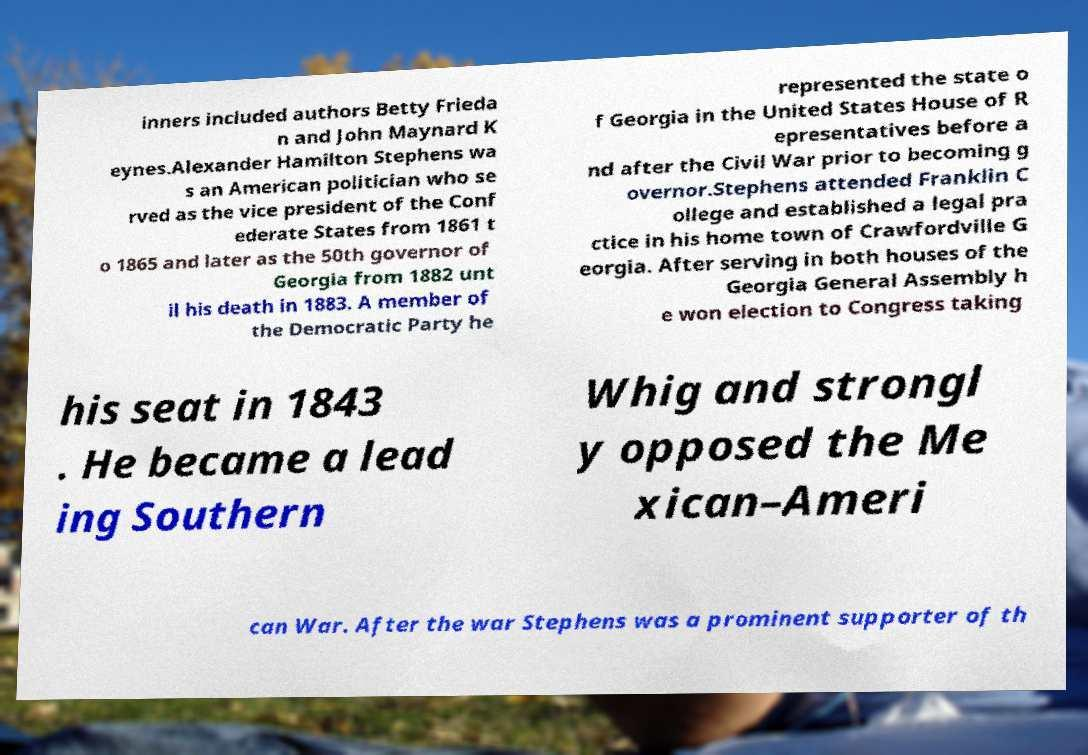I need the written content from this picture converted into text. Can you do that? inners included authors Betty Frieda n and John Maynard K eynes.Alexander Hamilton Stephens wa s an American politician who se rved as the vice president of the Conf ederate States from 1861 t o 1865 and later as the 50th governor of Georgia from 1882 unt il his death in 1883. A member of the Democratic Party he represented the state o f Georgia in the United States House of R epresentatives before a nd after the Civil War prior to becoming g overnor.Stephens attended Franklin C ollege and established a legal pra ctice in his home town of Crawfordville G eorgia. After serving in both houses of the Georgia General Assembly h e won election to Congress taking his seat in 1843 . He became a lead ing Southern Whig and strongl y opposed the Me xican–Ameri can War. After the war Stephens was a prominent supporter of th 